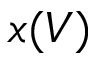Convert formula to latex. <formula><loc_0><loc_0><loc_500><loc_500>x ( V )</formula> 